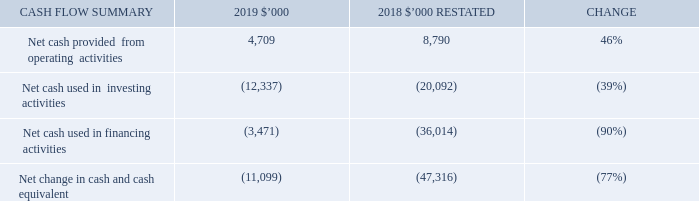Financial position and cash flow
Capital expenditure and cash flow
Net operating cash inflow was $4,709,000, which was $4,081,000 lower than last year. The reduction in operating revenue was offset by lower operational costs. However, net cash was impacted by the increase in trail to upfront revenue mix. In addition, as a result of the loss position reported for FY18, the Group received a net tax refund of $2,327,000 during the year, compared to the prior year net tax paid of $172,000.
Net investing cash outflows for the year was $12,337,000. The $7,755,000 decrease in spend in investing activities relates to the Group’s controlling interest acquisition of iMoney in December 2017.
Net financing cash outflows for the 2019 year totalled $3,471,000. This included $2,839,000 lease payments and $497,000 interest expense related to leases. The material decrease against the prior year comparative period relates to $32,918,000 paid in share buy-backs and dividends in the prior period.
What is the percentage change in the net cash provided from operating activities? 46%. What is the percentage change in the net cash provided from investing activities? (39%). What is the percentage change in the net cash provided from financing activities? (90%). What is the change in the net cash provided from operating activities from 2018 to 2019?
Answer scale should be: thousand. 4,709-8,790
Answer: -4081. What is the change in Net cash used in financing activities from 2018 to 2019?
Answer scale should be: thousand. (3,471)-(36,014)
Answer: 32543. What is the change in Net change in cash and cash equivalent from 2018 to 2019?
Answer scale should be: thousand. (11,099)-(47,316)
Answer: 36217. 